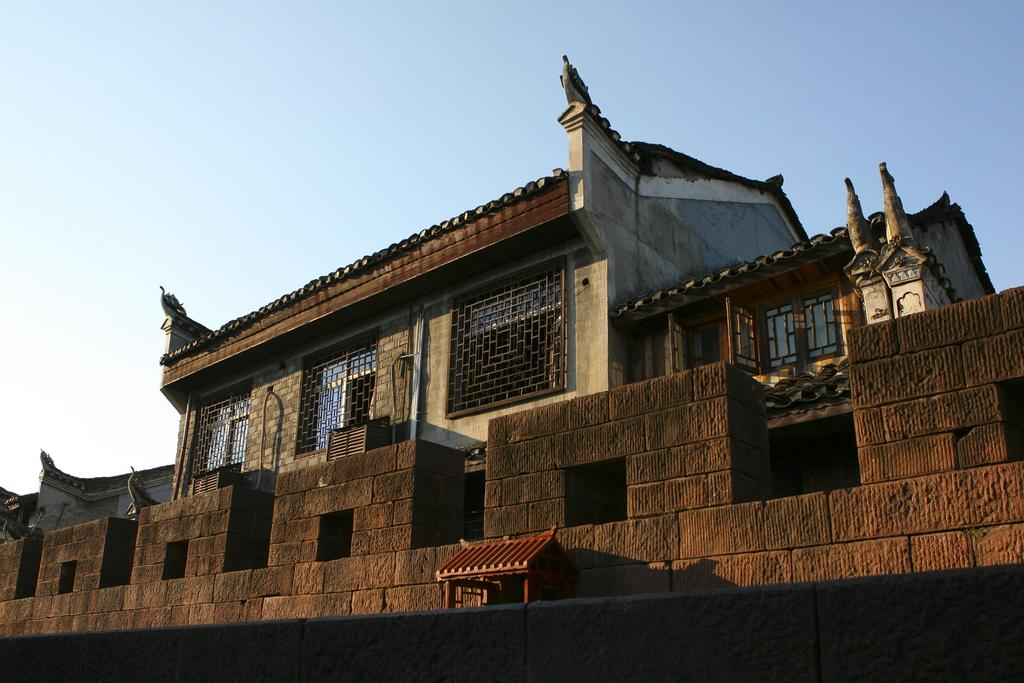What type of structure is visible in the image? There is a building in the image. What material is used for the windows of the building? The building has glass windows. What other architectural feature can be seen on the building? The building has metal grills. Where is the coach parked in the image? There is no coach present in the image. What is the elbow used for in the image? There is no elbow present in the image. 